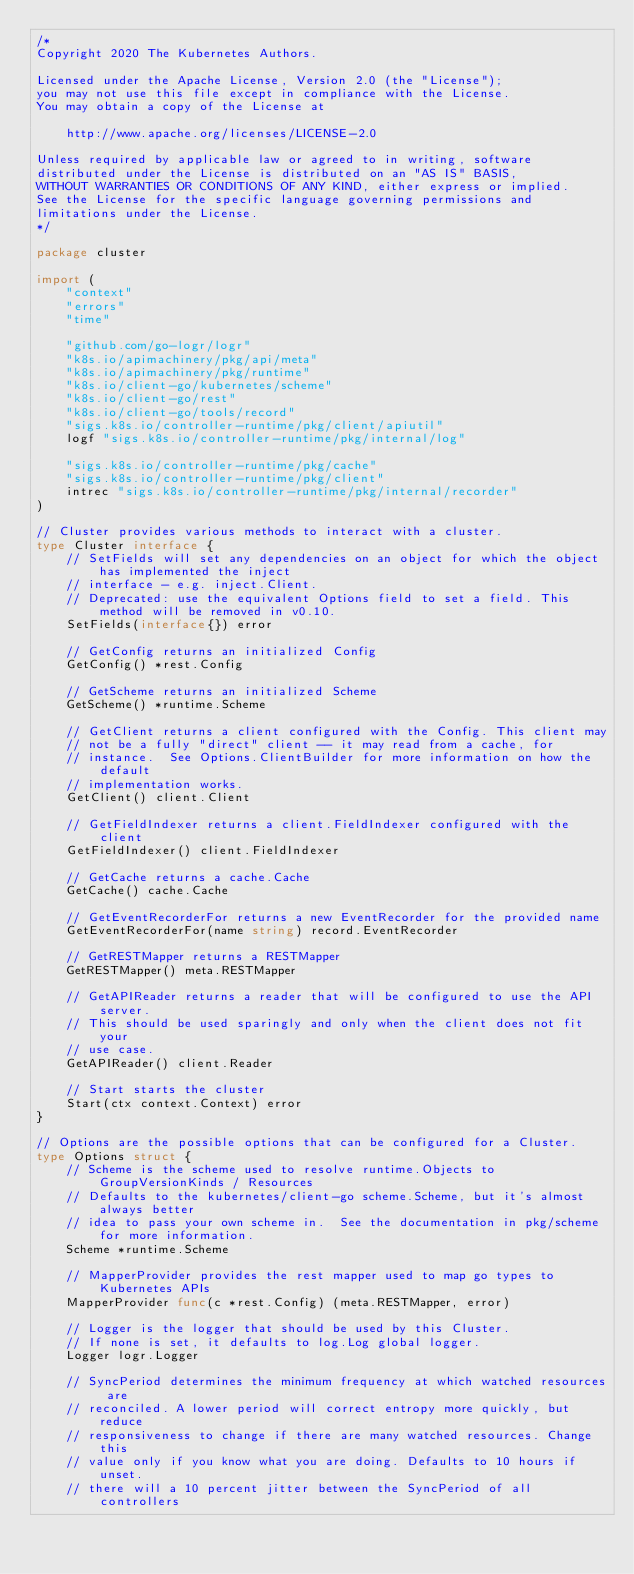<code> <loc_0><loc_0><loc_500><loc_500><_Go_>/*
Copyright 2020 The Kubernetes Authors.

Licensed under the Apache License, Version 2.0 (the "License");
you may not use this file except in compliance with the License.
You may obtain a copy of the License at

    http://www.apache.org/licenses/LICENSE-2.0

Unless required by applicable law or agreed to in writing, software
distributed under the License is distributed on an "AS IS" BASIS,
WITHOUT WARRANTIES OR CONDITIONS OF ANY KIND, either express or implied.
See the License for the specific language governing permissions and
limitations under the License.
*/

package cluster

import (
	"context"
	"errors"
	"time"

	"github.com/go-logr/logr"
	"k8s.io/apimachinery/pkg/api/meta"
	"k8s.io/apimachinery/pkg/runtime"
	"k8s.io/client-go/kubernetes/scheme"
	"k8s.io/client-go/rest"
	"k8s.io/client-go/tools/record"
	"sigs.k8s.io/controller-runtime/pkg/client/apiutil"
	logf "sigs.k8s.io/controller-runtime/pkg/internal/log"

	"sigs.k8s.io/controller-runtime/pkg/cache"
	"sigs.k8s.io/controller-runtime/pkg/client"
	intrec "sigs.k8s.io/controller-runtime/pkg/internal/recorder"
)

// Cluster provides various methods to interact with a cluster.
type Cluster interface {
	// SetFields will set any dependencies on an object for which the object has implemented the inject
	// interface - e.g. inject.Client.
	// Deprecated: use the equivalent Options field to set a field. This method will be removed in v0.10.
	SetFields(interface{}) error

	// GetConfig returns an initialized Config
	GetConfig() *rest.Config

	// GetScheme returns an initialized Scheme
	GetScheme() *runtime.Scheme

	// GetClient returns a client configured with the Config. This client may
	// not be a fully "direct" client -- it may read from a cache, for
	// instance.  See Options.ClientBuilder for more information on how the default
	// implementation works.
	GetClient() client.Client

	// GetFieldIndexer returns a client.FieldIndexer configured with the client
	GetFieldIndexer() client.FieldIndexer

	// GetCache returns a cache.Cache
	GetCache() cache.Cache

	// GetEventRecorderFor returns a new EventRecorder for the provided name
	GetEventRecorderFor(name string) record.EventRecorder

	// GetRESTMapper returns a RESTMapper
	GetRESTMapper() meta.RESTMapper

	// GetAPIReader returns a reader that will be configured to use the API server.
	// This should be used sparingly and only when the client does not fit your
	// use case.
	GetAPIReader() client.Reader

	// Start starts the cluster
	Start(ctx context.Context) error
}

// Options are the possible options that can be configured for a Cluster.
type Options struct {
	// Scheme is the scheme used to resolve runtime.Objects to GroupVersionKinds / Resources
	// Defaults to the kubernetes/client-go scheme.Scheme, but it's almost always better
	// idea to pass your own scheme in.  See the documentation in pkg/scheme for more information.
	Scheme *runtime.Scheme

	// MapperProvider provides the rest mapper used to map go types to Kubernetes APIs
	MapperProvider func(c *rest.Config) (meta.RESTMapper, error)

	// Logger is the logger that should be used by this Cluster.
	// If none is set, it defaults to log.Log global logger.
	Logger logr.Logger

	// SyncPeriod determines the minimum frequency at which watched resources are
	// reconciled. A lower period will correct entropy more quickly, but reduce
	// responsiveness to change if there are many watched resources. Change this
	// value only if you know what you are doing. Defaults to 10 hours if unset.
	// there will a 10 percent jitter between the SyncPeriod of all controllers</code> 